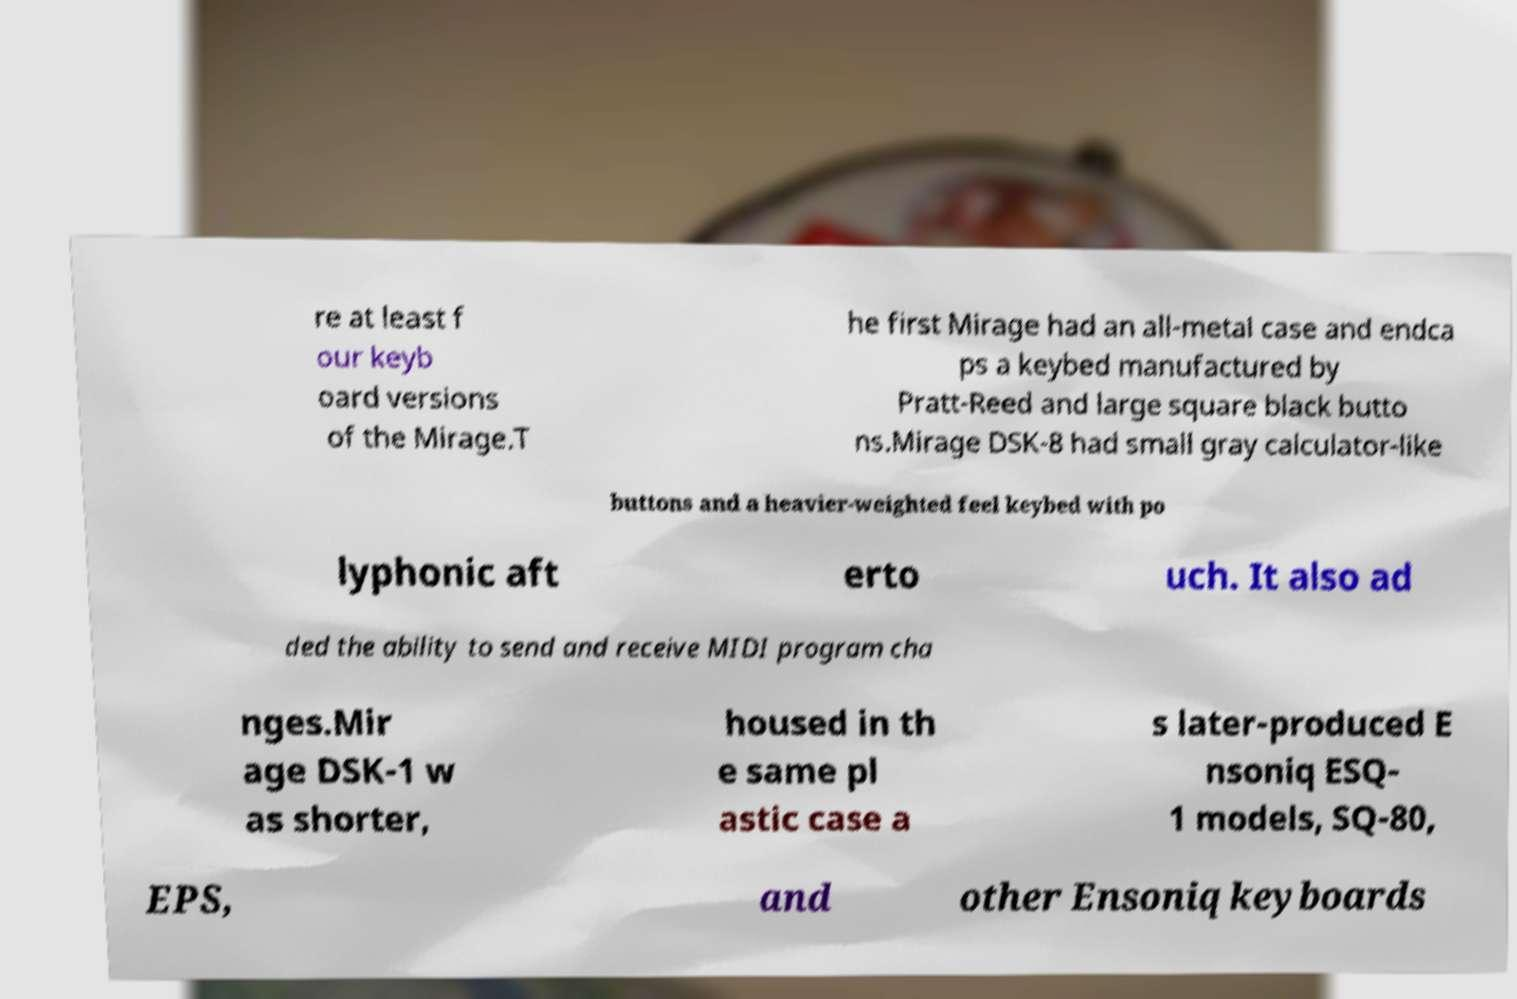I need the written content from this picture converted into text. Can you do that? re at least f our keyb oard versions of the Mirage.T he first Mirage had an all-metal case and endca ps a keybed manufactured by Pratt-Reed and large square black butto ns.Mirage DSK-8 had small gray calculator-like buttons and a heavier-weighted feel keybed with po lyphonic aft erto uch. It also ad ded the ability to send and receive MIDI program cha nges.Mir age DSK-1 w as shorter, housed in th e same pl astic case a s later-produced E nsoniq ESQ- 1 models, SQ-80, EPS, and other Ensoniq keyboards 